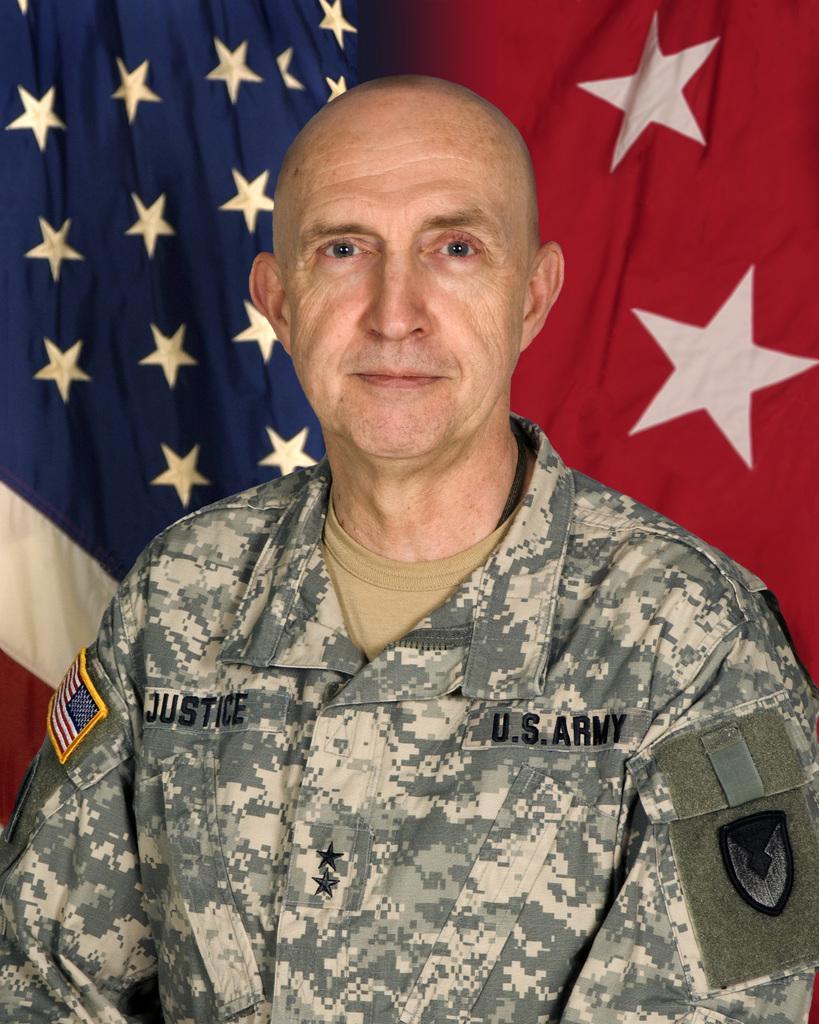Describe this image in one or two sentences. In the center of the image, we can see a person, wearing uniform and in the background, there is a flag. 